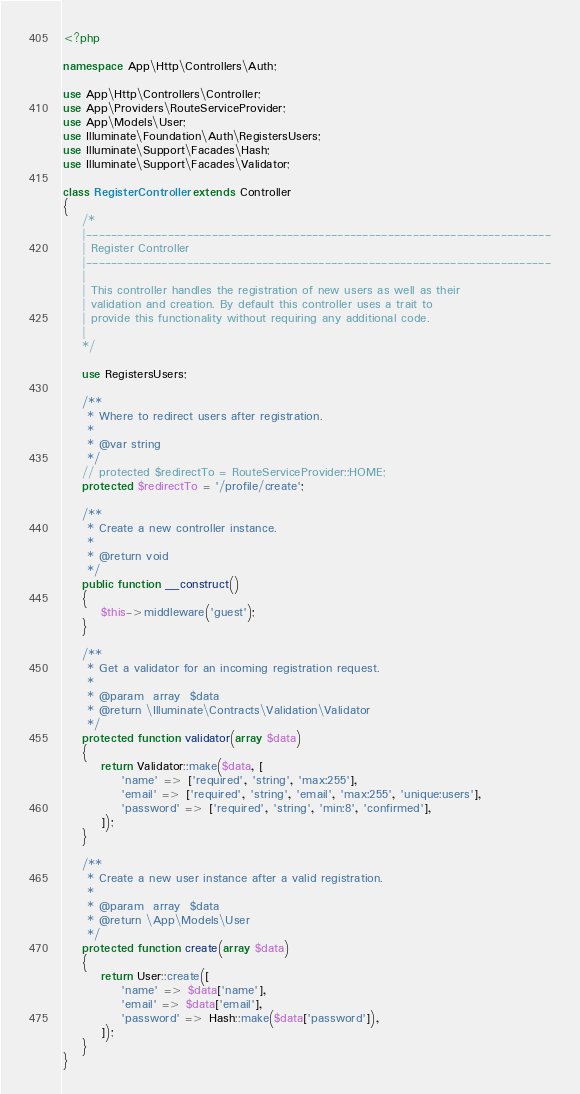Convert code to text. <code><loc_0><loc_0><loc_500><loc_500><_PHP_><?php

namespace App\Http\Controllers\Auth;

use App\Http\Controllers\Controller;
use App\Providers\RouteServiceProvider;
use App\Models\User;
use Illuminate\Foundation\Auth\RegistersUsers;
use Illuminate\Support\Facades\Hash;
use Illuminate\Support\Facades\Validator;

class RegisterController extends Controller
{
    /*
    |--------------------------------------------------------------------------
    | Register Controller
    |--------------------------------------------------------------------------
    |
    | This controller handles the registration of new users as well as their
    | validation and creation. By default this controller uses a trait to
    | provide this functionality without requiring any additional code.
    |
    */

    use RegistersUsers;

    /**
     * Where to redirect users after registration.
     *
     * @var string
     */
    // protected $redirectTo = RouteServiceProvider::HOME;
    protected $redirectTo = '/profile/create';

    /**
     * Create a new controller instance.
     *
     * @return void
     */
    public function __construct()
    {
        $this->middleware('guest');
    }

    /**
     * Get a validator for an incoming registration request.
     *
     * @param  array  $data
     * @return \Illuminate\Contracts\Validation\Validator
     */
    protected function validator(array $data)
    {
        return Validator::make($data, [
            'name' => ['required', 'string', 'max:255'],
            'email' => ['required', 'string', 'email', 'max:255', 'unique:users'],
            'password' => ['required', 'string', 'min:8', 'confirmed'],
        ]);
    }

    /**
     * Create a new user instance after a valid registration.
     *
     * @param  array  $data
     * @return \App\Models\User
     */
    protected function create(array $data)
    {
        return User::create([
            'name' => $data['name'],
            'email' => $data['email'],
            'password' => Hash::make($data['password']),
        ]);
    }
}
</code> 